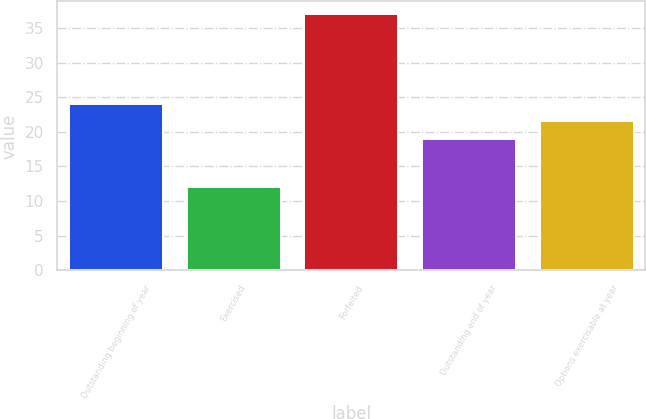Convert chart to OTSL. <chart><loc_0><loc_0><loc_500><loc_500><bar_chart><fcel>Outstanding beginning of year<fcel>Exercised<fcel>Forfeited<fcel>Outstanding end of year<fcel>Options exercisable at year<nl><fcel>24<fcel>12<fcel>37<fcel>19<fcel>21.5<nl></chart> 